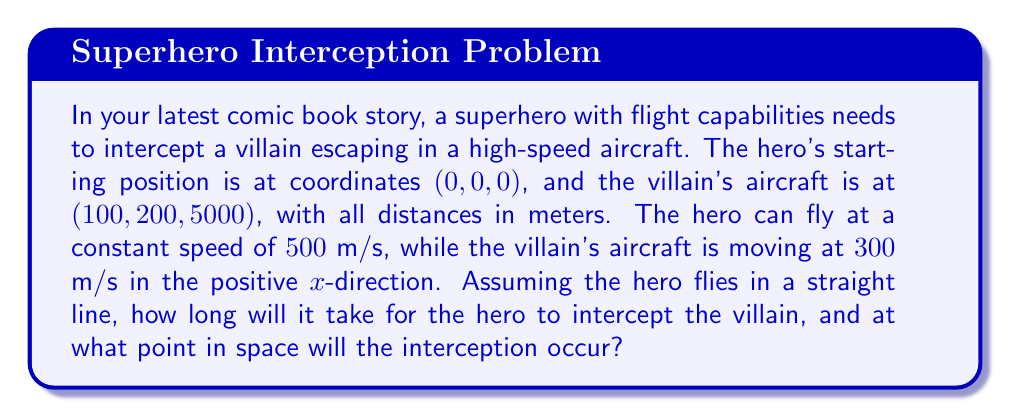Teach me how to tackle this problem. To solve this problem, we need to determine the time of interception and the point where the hero and villain meet. Let's approach this step-by-step:

1. Define variables:
   Let $t$ be the time of interception in seconds.
   Let $(x, y, z)$ be the interception point.

2. Express the villain's position at time $t$:
   $x_v = 100 + 300t$
   $y_v = 200$
   $z_v = 5000$

3. Express the hero's position at time $t$:
   $x_h = 500t \cos\theta \cos\phi$
   $y_h = 500t \sin\theta \cos\phi$
   $z_h = 500t \sin\phi$
   Where $\theta$ and $\phi$ are the horizontal and vertical angles of the hero's flight path.

4. Set up equations for interception:
   $x_v = x_h$
   $y_v = y_h$
   $z_v = z_h$

5. Substitute and solve:
   $100 + 300t = 500t \cos\theta \cos\phi$
   $200 = 500t \sin\theta \cos\phi$
   $5000 = 500t \sin\phi$

6. From the third equation:
   $\sin\phi = \frac{10}{t}$

7. Using the Pythagorean theorem:
   $\cos^2\phi = 1 - \sin^2\phi = 1 - (\frac{10}{t})^2$

8. Divide the second equation by the first:
   $\frac{200}{100 + 300t} = \tan\theta$

9. Square and add equations from steps 7 and 8:
   $(\frac{200}{100 + 300t})^2 + (\frac{10}{t})^2 = 1$

10. Solve this equation numerically (e.g., using Newton's method) to find $t \approx 10.54$ seconds.

11. Substitute back to find the interception point:
    $x = 100 + 300 * 10.54 \approx 3262$ m
    $y = 200$ m
    $z = 5000$ m
Answer: The hero will intercept the villain after approximately 10.54 seconds at the point (3262, 200, 5000) meters. 